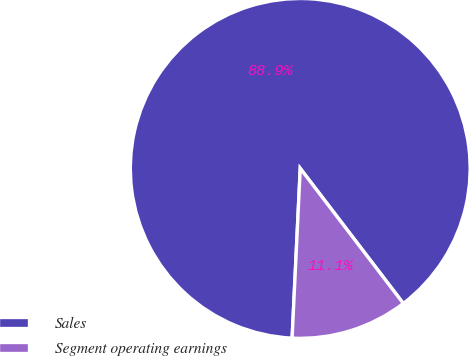Convert chart. <chart><loc_0><loc_0><loc_500><loc_500><pie_chart><fcel>Sales<fcel>Segment operating earnings<nl><fcel>88.86%<fcel>11.14%<nl></chart> 